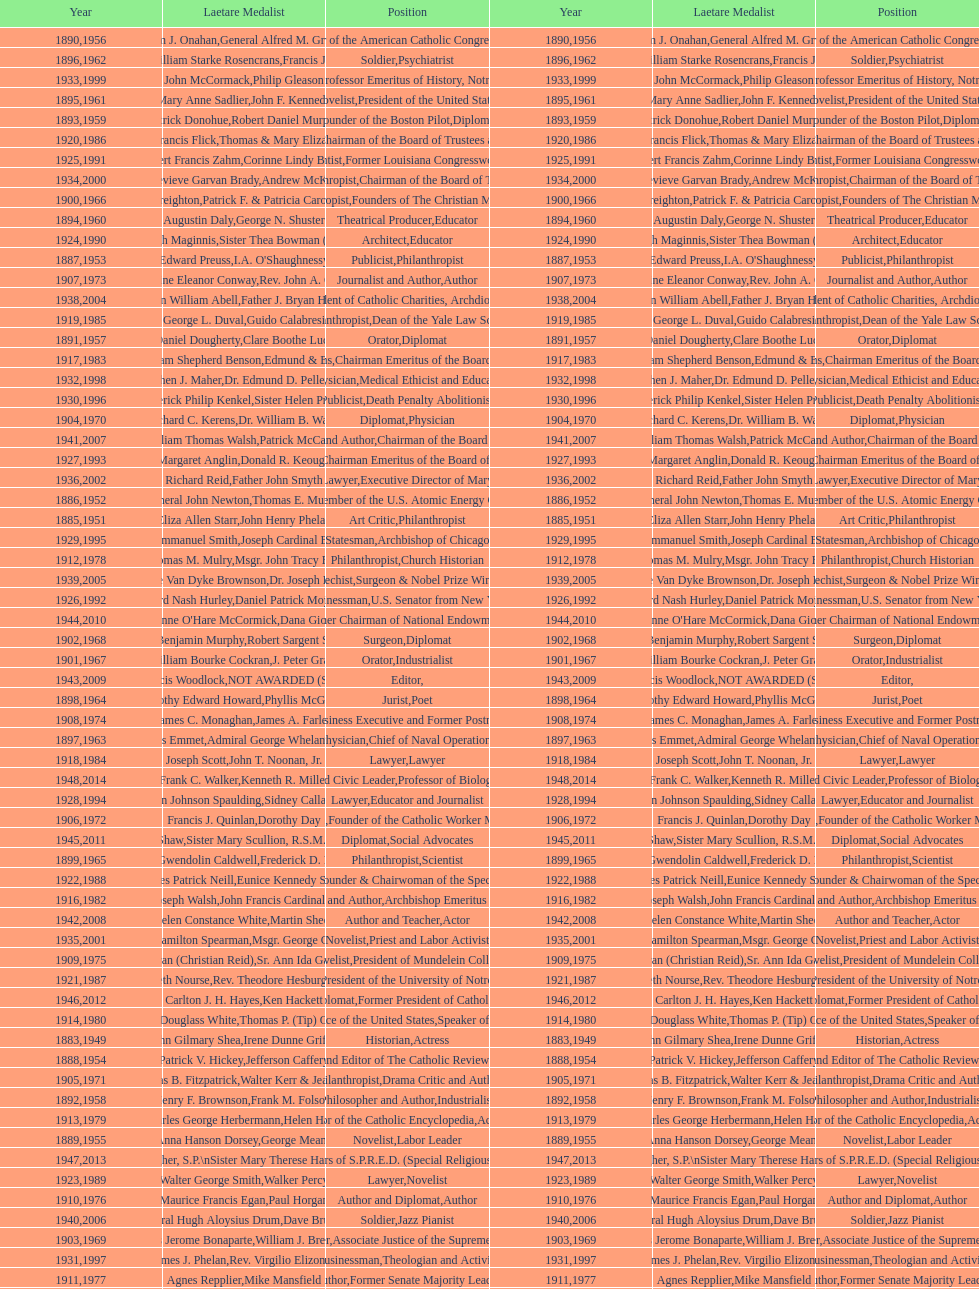What is the name of the laetare medalist listed before edward preuss? General John Newton. 